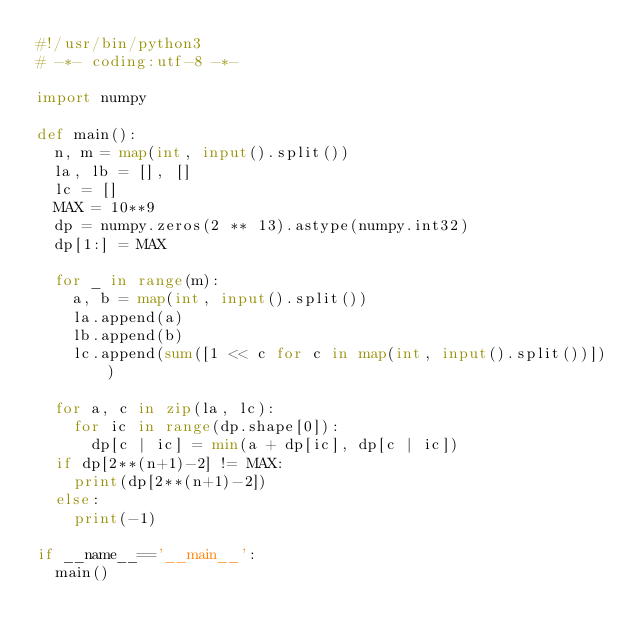Convert code to text. <code><loc_0><loc_0><loc_500><loc_500><_Python_>#!/usr/bin/python3
# -*- coding:utf-8 -*-

import numpy

def main():
  n, m = map(int, input().split())
  la, lb = [], []
  lc = []
  MAX = 10**9
  dp = numpy.zeros(2 ** 13).astype(numpy.int32)
  dp[1:] = MAX
  
  for _ in range(m):
    a, b = map(int, input().split())
    la.append(a)
    lb.append(b)
    lc.append(sum([1 << c for c in map(int, input().split())]))
    
  for a, c in zip(la, lc):
    for ic in range(dp.shape[0]):
      dp[c | ic] = min(a + dp[ic], dp[c | ic])
  if dp[2**(n+1)-2] != MAX:
    print(dp[2**(n+1)-2])
  else:
    print(-1)

if __name__=='__main__':
  main()

</code> 